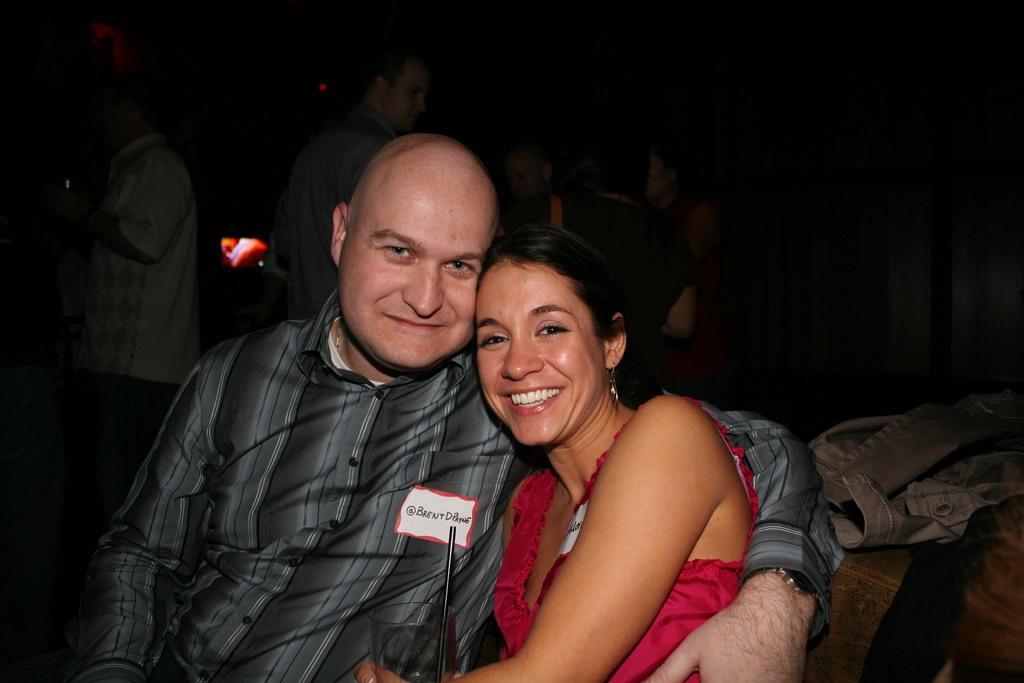Can you describe this image briefly? In this picture man and woman seated and I see a glass with straw in the woman's hand and on the back I see few people standing and it looks like a television on the back. 